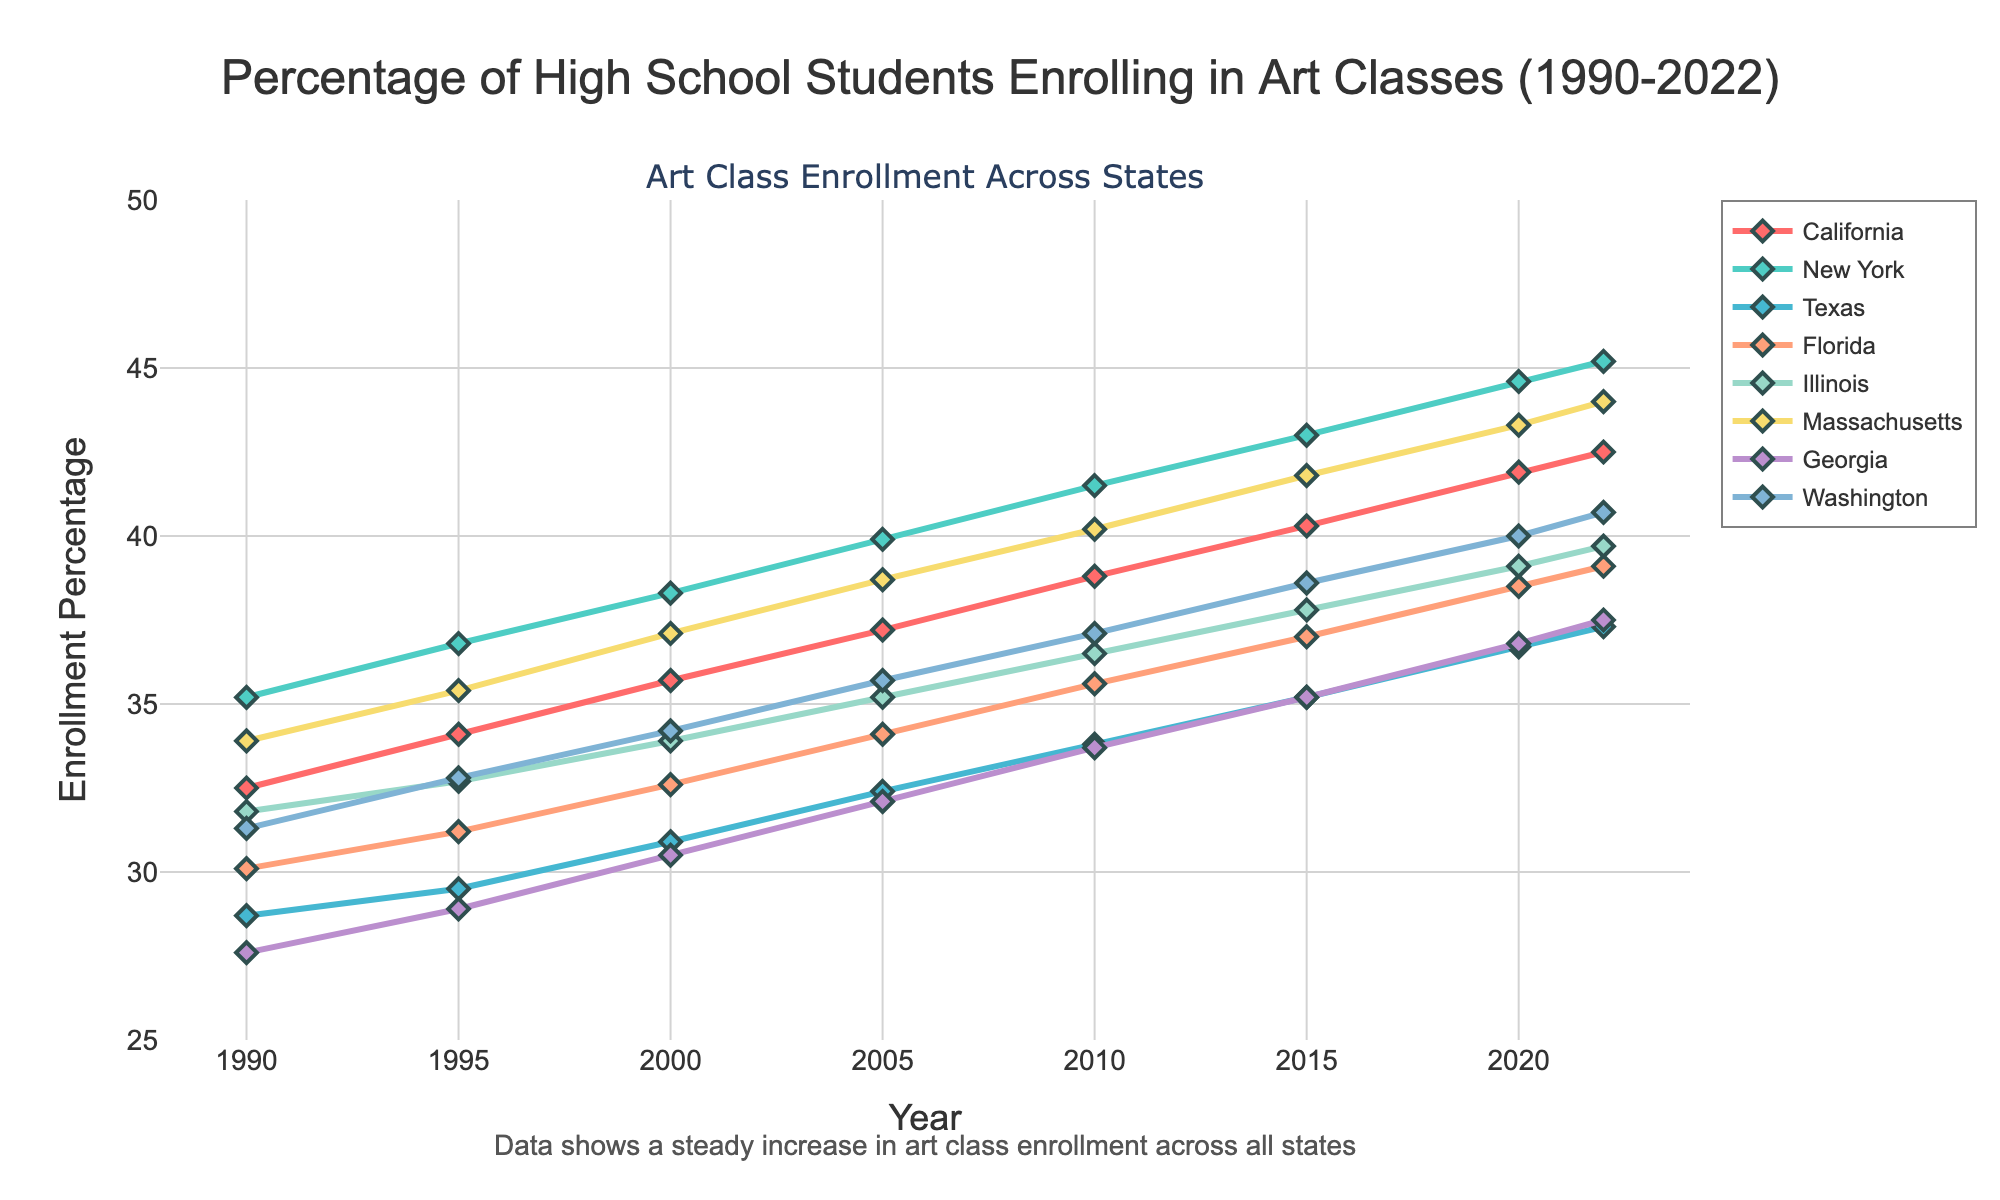What's the trend of art class enrollment in California from 1990 to 2022? From the chart, we observe the line representing California's enrollment percentage. It starts at 32.5% in 1990 and consistently rises to 42.5% in 2022. Therefore, the trend is an increase over the years.
Answer: Increasing trend Which state shows the highest art class enrollment percentage in 2022? By examining the endpoints of the lines in the year 2022 on the chart, New York's line reaches 45.2%, which is the highest among all states shown.
Answer: New York Compare the enrollment percentages in Texas and Florida in 2000. Which state has a higher percentage? Looking at the year 2000 on the chart, Texas is at 30.9% while Florida is at 32.6%. Therefore, Florida has a higher enrollment percentage than Texas in 2000.
Answer: Florida What is the average art class enrollment percentage in 2020 across all states depicted? Refer to the year 2020 for each state, their enrollment percentages are: California (41.9%), New York (44.6%), Texas (36.7%), Florida (38.5%), Illinois (39.1%), Massachusetts (43.3%), Georgia (36.8%), Washington (40.0%). The average is the sum divided by the number of states (8). (41.9 + 44.6 + 36.7 + 38.5 + 39.1 + 43.3 + 36.8 + 40.0) / 8 = 40.113%
Answer: 40.1% Which state had the smallest increase in art class enrollment percentage from 1990 to 2022? Subtract the 1990 values from the 2022 values for each state and compare. California: 42.5 - 32.5 = 10, New York: 45.2 - 35.2 = 10, Texas: 37.3 - 28.7 = 8.6, Florida: 39.1 - 30.1 = 9, Illinois: 39.7 - 31.8 = 7.9, Massachusetts: 44.0 - 33.9 = 10.1, Georgia: 37.5 - 27.6 = 9.9, Washington: 40.7 - 31.3 = 9.4. Illinois has the smallest increase (7.9%).
Answer: Illinois In which year did Massachusetts' art class enrollment percentage first surpass 40%? Follow the line representing Massachusetts and identify the first year it crosses the 40% mark. This occurs between 2010 and 2015. Checking the values, 2015 shows Massachusetts at 41.8%, hence 2015 is the required year.
Answer: 2015 Compare the overall trend from 1990 to 2022, which state's enrollment increased the most? Calculate the difference in enrollment percentages from 1990 to 2022 for each state: California (10), New York (10), Texas (8.6), Florida (9), Illinois (7.9), Massachusetts (10.1), Georgia (9.9), and Washington (9.4). Massachusetts increased the most with 10.1%.
Answer: Massachusetts How does the enrollment percentage change for Washington from 2005 to 2010? Identify the values for Washington in 2005 and 2010. In 2005, it's 35.7%, and in 2010, it's 37.1%. The change is 37.1 - 35.7 = 1.4%.
Answer: 1.4% increase Was there any year where all states had more than 30% enrollment in art classes? Check each year to see if every state had enrollment percentages above 30%. By inspection, 2000 onwards, all enrollment percentages are above 30%. Hence, from 2000 onwards all states had more than 30% enrollment.
Answer: Yes, from 2000 onwards 